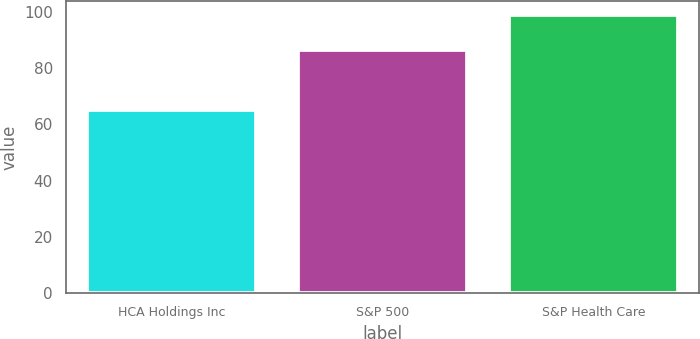Convert chart. <chart><loc_0><loc_0><loc_500><loc_500><bar_chart><fcel>HCA Holdings Inc<fcel>S&P 500<fcel>S&P Health Care<nl><fcel>64.99<fcel>86.25<fcel>98.9<nl></chart> 